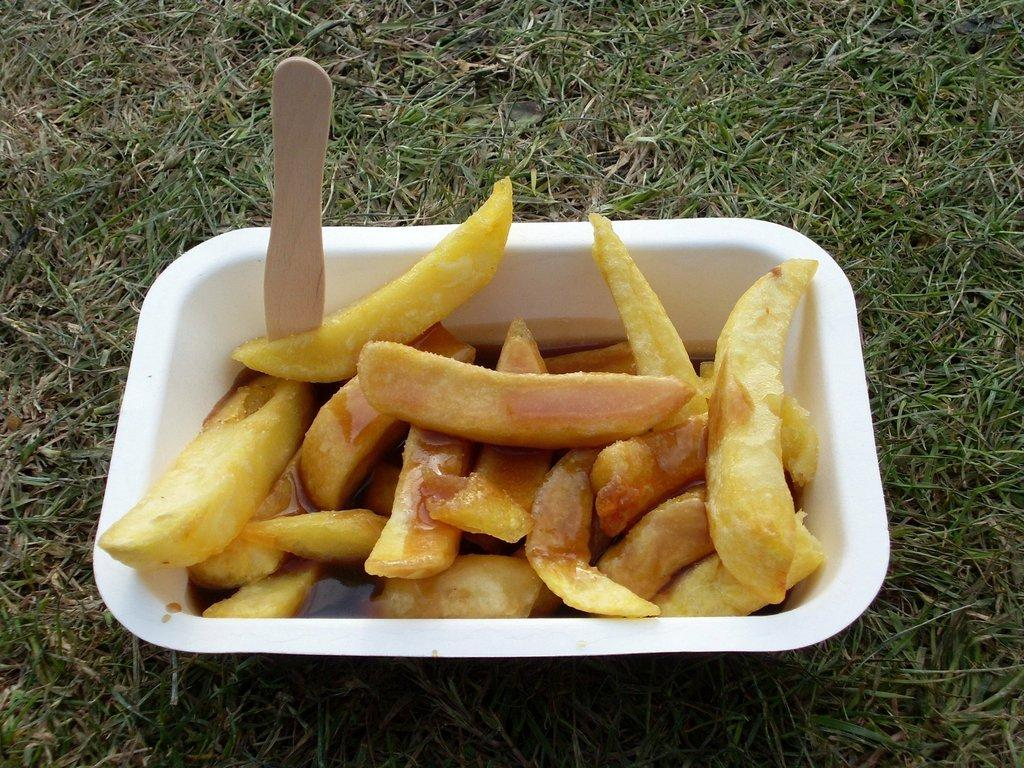What is in the bowl that is visible in the image? There is a food item in the bowl that is visible in the image. What can be seen on the ground in the image? There is a wooden object on the ground in the image. What type of fowl can be seen interacting with the wooden object in the image? There is no fowl present in the image; it only features a bowl with a food item and a wooden object on the ground. Who is the friend that is sitting next to the bowl in the image? There is no person or friend present in the image; it only features a bowl with a food item and a wooden object on the ground. 